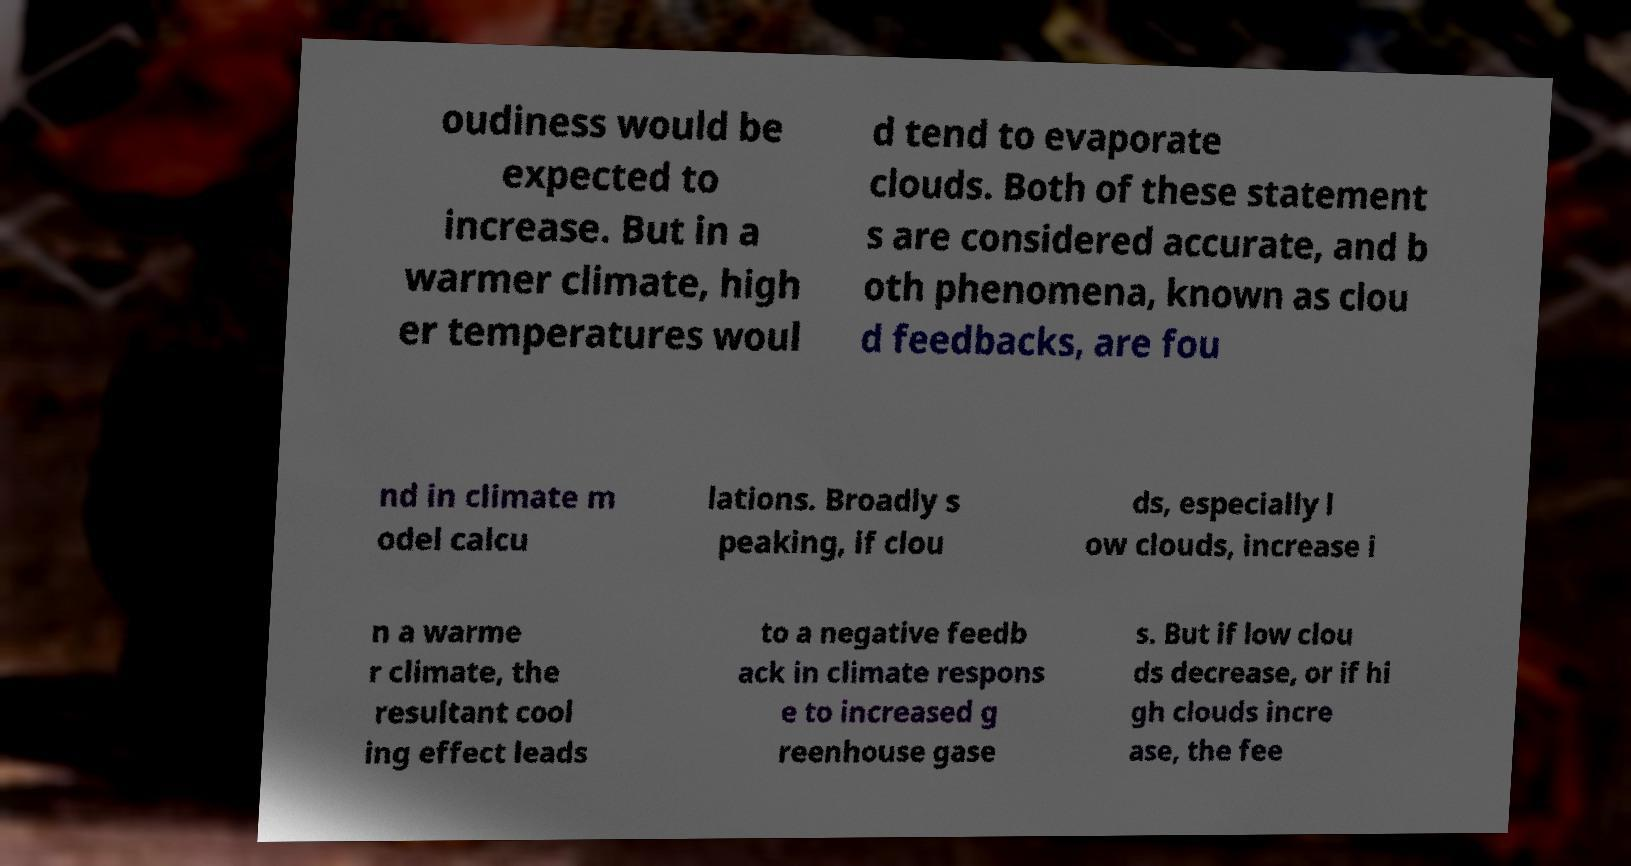Could you extract and type out the text from this image? oudiness would be expected to increase. But in a warmer climate, high er temperatures woul d tend to evaporate clouds. Both of these statement s are considered accurate, and b oth phenomena, known as clou d feedbacks, are fou nd in climate m odel calcu lations. Broadly s peaking, if clou ds, especially l ow clouds, increase i n a warme r climate, the resultant cool ing effect leads to a negative feedb ack in climate respons e to increased g reenhouse gase s. But if low clou ds decrease, or if hi gh clouds incre ase, the fee 